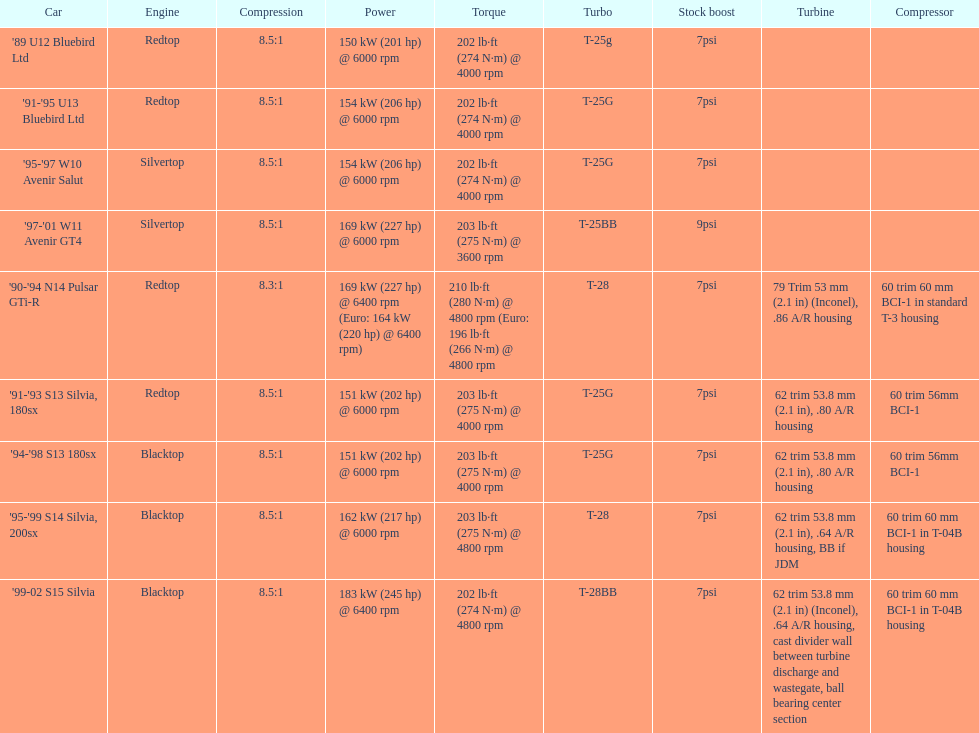After 1999, which engines were employed? Silvertop, Blacktop. Can you give me this table as a dict? {'header': ['Car', 'Engine', 'Compression', 'Power', 'Torque', 'Turbo', 'Stock boost', 'Turbine', 'Compressor'], 'rows': [["'89 U12 Bluebird Ltd", 'Redtop', '8.5:1', '150\xa0kW (201\xa0hp) @ 6000 rpm', '202\xa0lb·ft (274\xa0N·m) @ 4000 rpm', 'T-25g', '7psi', '', ''], ["'91-'95 U13 Bluebird Ltd", 'Redtop', '8.5:1', '154\xa0kW (206\xa0hp) @ 6000 rpm', '202\xa0lb·ft (274\xa0N·m) @ 4000 rpm', 'T-25G', '7psi', '', ''], ["'95-'97 W10 Avenir Salut", 'Silvertop', '8.5:1', '154\xa0kW (206\xa0hp) @ 6000 rpm', '202\xa0lb·ft (274\xa0N·m) @ 4000 rpm', 'T-25G', '7psi', '', ''], ["'97-'01 W11 Avenir GT4", 'Silvertop', '8.5:1', '169\xa0kW (227\xa0hp) @ 6000 rpm', '203\xa0lb·ft (275\xa0N·m) @ 3600 rpm', 'T-25BB', '9psi', '', ''], ["'90-'94 N14 Pulsar GTi-R", 'Redtop', '8.3:1', '169\xa0kW (227\xa0hp) @ 6400 rpm (Euro: 164\xa0kW (220\xa0hp) @ 6400 rpm)', '210\xa0lb·ft (280\xa0N·m) @ 4800 rpm (Euro: 196\xa0lb·ft (266\xa0N·m) @ 4800 rpm', 'T-28', '7psi', '79 Trim 53\xa0mm (2.1\xa0in) (Inconel), .86 A/R housing', '60 trim 60\xa0mm BCI-1 in standard T-3 housing'], ["'91-'93 S13 Silvia, 180sx", 'Redtop', '8.5:1', '151\xa0kW (202\xa0hp) @ 6000 rpm', '203\xa0lb·ft (275\xa0N·m) @ 4000 rpm', 'T-25G', '7psi', '62 trim 53.8\xa0mm (2.1\xa0in), .80 A/R housing', '60 trim 56mm BCI-1'], ["'94-'98 S13 180sx", 'Blacktop', '8.5:1', '151\xa0kW (202\xa0hp) @ 6000 rpm', '203\xa0lb·ft (275\xa0N·m) @ 4000 rpm', 'T-25G', '7psi', '62 trim 53.8\xa0mm (2.1\xa0in), .80 A/R housing', '60 trim 56mm BCI-1'], ["'95-'99 S14 Silvia, 200sx", 'Blacktop', '8.5:1', '162\xa0kW (217\xa0hp) @ 6000 rpm', '203\xa0lb·ft (275\xa0N·m) @ 4800 rpm', 'T-28', '7psi', '62 trim 53.8\xa0mm (2.1\xa0in), .64 A/R housing, BB if JDM', '60 trim 60\xa0mm BCI-1 in T-04B housing'], ["'99-02 S15 Silvia", 'Blacktop', '8.5:1', '183\xa0kW (245\xa0hp) @ 6400 rpm', '202\xa0lb·ft (274\xa0N·m) @ 4800 rpm', 'T-28BB', '7psi', '62 trim 53.8\xa0mm (2.1\xa0in) (Inconel), .64 A/R housing, cast divider wall between turbine discharge and wastegate, ball bearing center section', '60 trim 60\xa0mm BCI-1 in T-04B housing']]} 